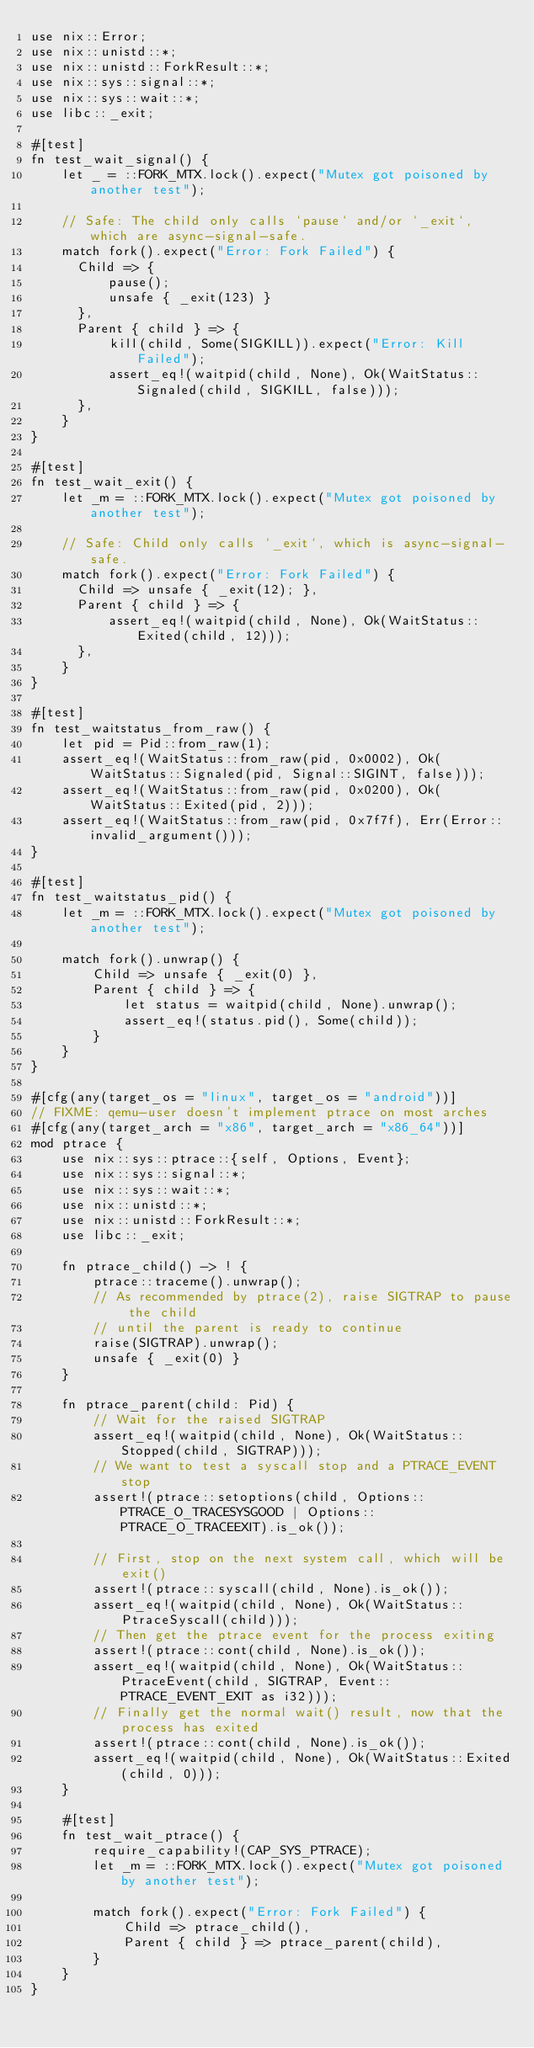Convert code to text. <code><loc_0><loc_0><loc_500><loc_500><_Rust_>use nix::Error;
use nix::unistd::*;
use nix::unistd::ForkResult::*;
use nix::sys::signal::*;
use nix::sys::wait::*;
use libc::_exit;

#[test]
fn test_wait_signal() {
    let _ = ::FORK_MTX.lock().expect("Mutex got poisoned by another test");

    // Safe: The child only calls `pause` and/or `_exit`, which are async-signal-safe.
    match fork().expect("Error: Fork Failed") {
      Child => {
          pause();
          unsafe { _exit(123) }
      },
      Parent { child } => {
          kill(child, Some(SIGKILL)).expect("Error: Kill Failed");
          assert_eq!(waitpid(child, None), Ok(WaitStatus::Signaled(child, SIGKILL, false)));
      },
    }
}

#[test]
fn test_wait_exit() {
    let _m = ::FORK_MTX.lock().expect("Mutex got poisoned by another test");

    // Safe: Child only calls `_exit`, which is async-signal-safe.
    match fork().expect("Error: Fork Failed") {
      Child => unsafe { _exit(12); },
      Parent { child } => {
          assert_eq!(waitpid(child, None), Ok(WaitStatus::Exited(child, 12)));
      },
    }
}

#[test]
fn test_waitstatus_from_raw() {
    let pid = Pid::from_raw(1);
    assert_eq!(WaitStatus::from_raw(pid, 0x0002), Ok(WaitStatus::Signaled(pid, Signal::SIGINT, false)));
    assert_eq!(WaitStatus::from_raw(pid, 0x0200), Ok(WaitStatus::Exited(pid, 2)));
    assert_eq!(WaitStatus::from_raw(pid, 0x7f7f), Err(Error::invalid_argument()));
}

#[test]
fn test_waitstatus_pid() {
    let _m = ::FORK_MTX.lock().expect("Mutex got poisoned by another test");

    match fork().unwrap() {
        Child => unsafe { _exit(0) },
        Parent { child } => {
            let status = waitpid(child, None).unwrap();
            assert_eq!(status.pid(), Some(child));
        }
    }
}

#[cfg(any(target_os = "linux", target_os = "android"))]
// FIXME: qemu-user doesn't implement ptrace on most arches
#[cfg(any(target_arch = "x86", target_arch = "x86_64"))]
mod ptrace {
    use nix::sys::ptrace::{self, Options, Event};
    use nix::sys::signal::*;
    use nix::sys::wait::*;
    use nix::unistd::*;
    use nix::unistd::ForkResult::*;
    use libc::_exit;

    fn ptrace_child() -> ! {
        ptrace::traceme().unwrap();
        // As recommended by ptrace(2), raise SIGTRAP to pause the child
        // until the parent is ready to continue
        raise(SIGTRAP).unwrap();
        unsafe { _exit(0) }
    }

    fn ptrace_parent(child: Pid) {
        // Wait for the raised SIGTRAP
        assert_eq!(waitpid(child, None), Ok(WaitStatus::Stopped(child, SIGTRAP)));
        // We want to test a syscall stop and a PTRACE_EVENT stop
        assert!(ptrace::setoptions(child, Options::PTRACE_O_TRACESYSGOOD | Options::PTRACE_O_TRACEEXIT).is_ok());

        // First, stop on the next system call, which will be exit()
        assert!(ptrace::syscall(child, None).is_ok());
        assert_eq!(waitpid(child, None), Ok(WaitStatus::PtraceSyscall(child)));
        // Then get the ptrace event for the process exiting
        assert!(ptrace::cont(child, None).is_ok());
        assert_eq!(waitpid(child, None), Ok(WaitStatus::PtraceEvent(child, SIGTRAP, Event::PTRACE_EVENT_EXIT as i32)));
        // Finally get the normal wait() result, now that the process has exited
        assert!(ptrace::cont(child, None).is_ok());
        assert_eq!(waitpid(child, None), Ok(WaitStatus::Exited(child, 0)));
    }

    #[test]
    fn test_wait_ptrace() {
        require_capability!(CAP_SYS_PTRACE);
        let _m = ::FORK_MTX.lock().expect("Mutex got poisoned by another test");

        match fork().expect("Error: Fork Failed") {
            Child => ptrace_child(),
            Parent { child } => ptrace_parent(child),
        }
    }
}
</code> 